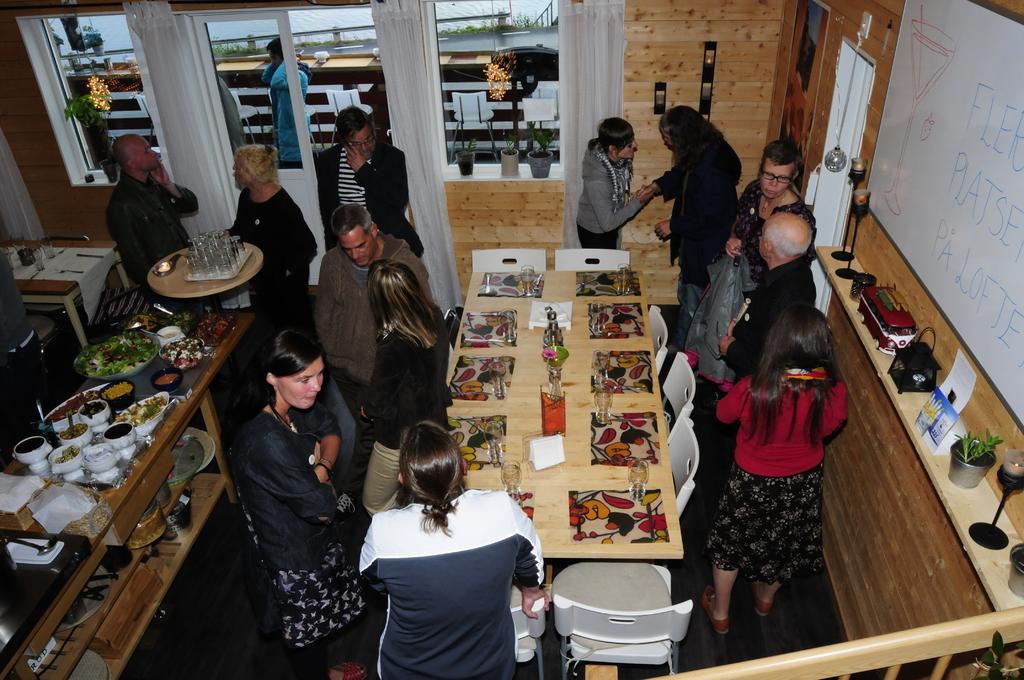Can you describe this image briefly? In this picture we see a wooden room with many people, tables and chairs inside it. 